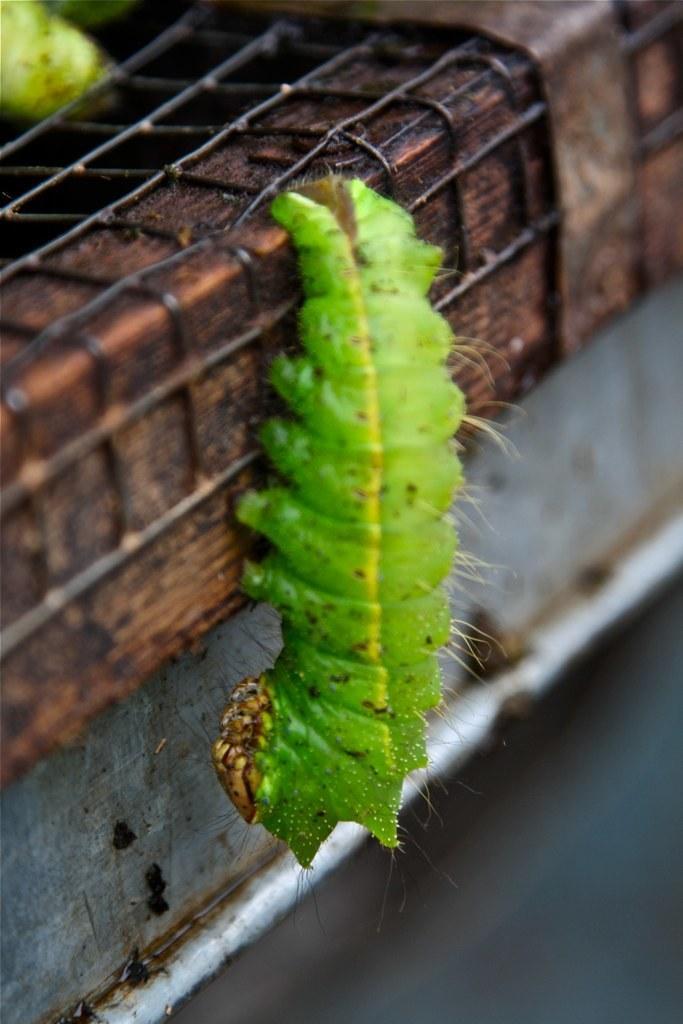How would you summarize this image in a sentence or two? In this picture I can see a green color caterpillar and I can see a metal fence. 